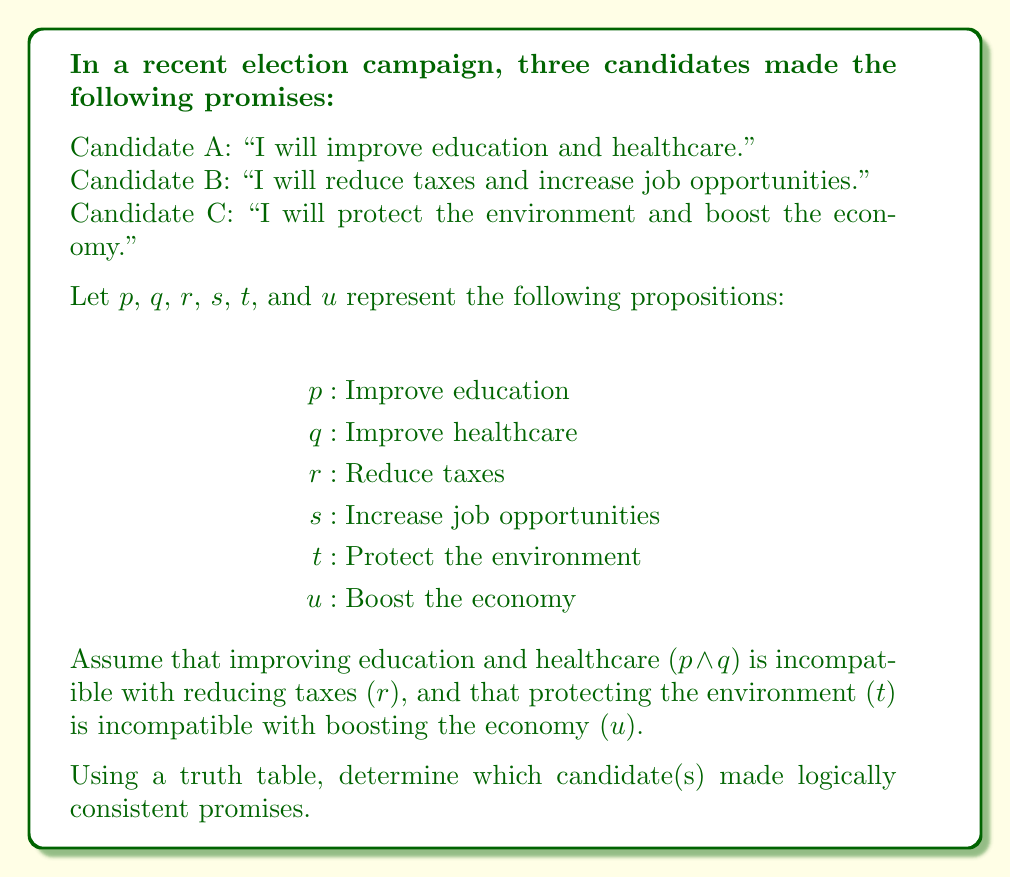What is the answer to this math problem? To evaluate the logical consistency of the campaign promises, we need to construct a truth table that incorporates the given incompatibilities. We'll use the following compound propositions to represent each candidate's promises:

Candidate A: $p \land q$
Candidate B: $r \land s$
Candidate C: $t \land u$

Given incompatibilities:
1. $(p \land q) \rightarrow \neg r$
2. $t \rightarrow \neg u$

Let's construct a truth table with columns for $p$, $q$, $r$, $s$, $t$, $u$, $(p \land q)$, $(r \land s)$, and $(t \land u)$:

$$
\begin{array}{cccccc|ccc}
p & q & r & s & t & u & (p \land q) & (r \land s) & (t \land u) \\
\hline
T & T & T & T & T & T & T & T & T \\
T & T & T & T & T & F & T & T & F \\
T & T & T & T & F & T & T & T & F \\
T & T & T & T & F & F & T & T & F \\
T & T & T & F & T & T & T & F & T \\
T & T & T & F & T & F & T & F & F \\
T & T & T & F & F & T & T & F & F \\
T & T & T & F & F & F & T & F & F \\
T & T & F & T & T & T & T & F & T \\
T & T & F & T & T & F & T & F & F \\
T & T & F & T & F & T & T & F & F \\
T & T & F & T & F & F & T & F & F \\
T & T & F & F & T & T & T & F & T \\
T & T & F & F & T & F & T & F & F \\
T & T & F & F & F & T & T & F & F \\
T & T & F & F & F & F & T & F & F \\
\end{array}
$$

(Note: The table continues for 64 rows, but we've shown only the first 16 for brevity)

Now, we need to eliminate rows that violate the given incompatibilities:

1. Remove rows where $(p \land q)$ is true and $r$ is true
2. Remove rows where $t$ is true and $u$ is true

After applying these constraints, we're left with the following valid combinations:

$$
\begin{array}{cccccc|ccc}
p & q & r & s & t & u & (p \land q) & (r \land s) & (t \land u) \\
\hline
T & T & F & T & F & T & T & F & F \\
T & T & F & T & F & F & T & F & F \\
T & T & F & F & F & T & T & F & F \\
T & T & F & F & F & F & T & F & F \\
F & T & T & T & F & T & F & T & F \\
F & T & T & T & F & F & F & T & F \\
F & F & T & T & F & T & F & T & F \\
F & F & T & T & F & F & F & T & F \\
\end{array}
$$

Analyzing the results:

1. Candidate A $(p \land q)$: Logically consistent (true in 4 rows)
2. Candidate B $(r \land s)$: Logically consistent (true in 4 rows)
3. Candidate C $(t \land u)$: Logically inconsistent (false in all rows)
Answer: Candidates A and B made logically consistent promises, while Candidate C's promises are logically inconsistent given the stated incompatibilities. 